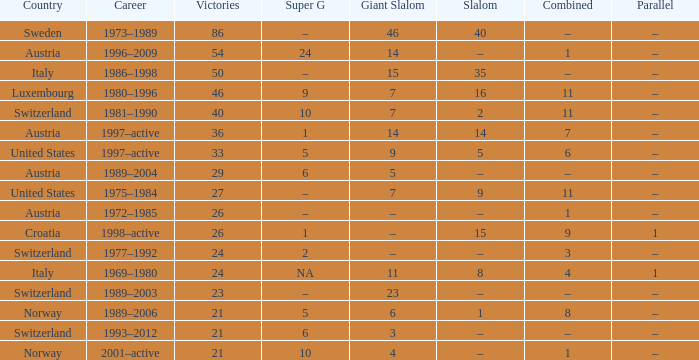What super g experienced a professional life between 1980 and 1996? 9.0. 